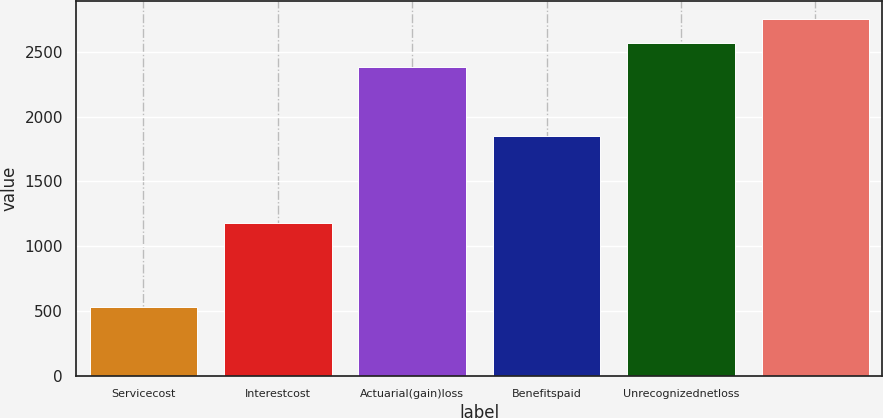<chart> <loc_0><loc_0><loc_500><loc_500><bar_chart><fcel>Servicecost<fcel>Interestcost<fcel>Actuarial(gain)loss<fcel>Benefitspaid<fcel>Unrecognizednetloss<fcel>Unnamed: 5<nl><fcel>532<fcel>1175<fcel>2380<fcel>1850<fcel>2568.8<fcel>2757.6<nl></chart> 